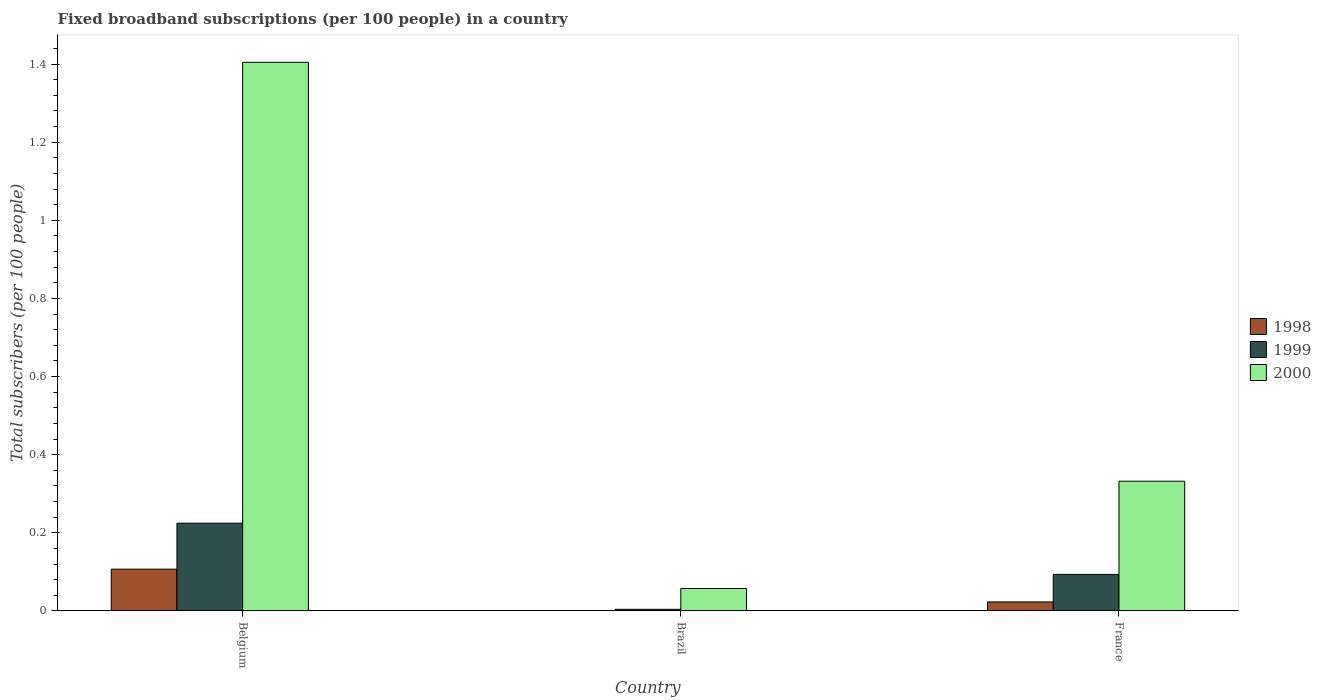How many different coloured bars are there?
Give a very brief answer. 3. How many groups of bars are there?
Offer a terse response. 3. Are the number of bars per tick equal to the number of legend labels?
Offer a terse response. Yes. How many bars are there on the 3rd tick from the left?
Your answer should be compact. 3. How many bars are there on the 1st tick from the right?
Your answer should be very brief. 3. What is the label of the 2nd group of bars from the left?
Provide a succinct answer. Brazil. In how many cases, is the number of bars for a given country not equal to the number of legend labels?
Your answer should be very brief. 0. What is the number of broadband subscriptions in 1999 in Brazil?
Offer a terse response. 0. Across all countries, what is the maximum number of broadband subscriptions in 2000?
Your answer should be very brief. 1.4. Across all countries, what is the minimum number of broadband subscriptions in 1998?
Offer a terse response. 0. In which country was the number of broadband subscriptions in 1999 maximum?
Offer a very short reply. Belgium. In which country was the number of broadband subscriptions in 1999 minimum?
Your answer should be compact. Brazil. What is the total number of broadband subscriptions in 2000 in the graph?
Offer a terse response. 1.79. What is the difference between the number of broadband subscriptions in 2000 in Brazil and that in France?
Offer a terse response. -0.27. What is the difference between the number of broadband subscriptions in 2000 in France and the number of broadband subscriptions in 1999 in Belgium?
Provide a succinct answer. 0.11. What is the average number of broadband subscriptions in 1999 per country?
Give a very brief answer. 0.11. What is the difference between the number of broadband subscriptions of/in 1999 and number of broadband subscriptions of/in 2000 in Belgium?
Offer a terse response. -1.18. What is the ratio of the number of broadband subscriptions in 1998 in Brazil to that in France?
Ensure brevity in your answer.  0.03. What is the difference between the highest and the second highest number of broadband subscriptions in 1998?
Give a very brief answer. 0.08. What is the difference between the highest and the lowest number of broadband subscriptions in 1998?
Keep it short and to the point. 0.11. In how many countries, is the number of broadband subscriptions in 1998 greater than the average number of broadband subscriptions in 1998 taken over all countries?
Make the answer very short. 1. What does the 3rd bar from the left in France represents?
Your response must be concise. 2000. Is it the case that in every country, the sum of the number of broadband subscriptions in 1998 and number of broadband subscriptions in 2000 is greater than the number of broadband subscriptions in 1999?
Make the answer very short. Yes. How many bars are there?
Your answer should be very brief. 9. Are all the bars in the graph horizontal?
Provide a short and direct response. No. What is the difference between two consecutive major ticks on the Y-axis?
Offer a very short reply. 0.2. Are the values on the major ticks of Y-axis written in scientific E-notation?
Offer a very short reply. No. Does the graph contain grids?
Keep it short and to the point. No. Where does the legend appear in the graph?
Your response must be concise. Center right. What is the title of the graph?
Provide a succinct answer. Fixed broadband subscriptions (per 100 people) in a country. Does "1962" appear as one of the legend labels in the graph?
Offer a terse response. No. What is the label or title of the X-axis?
Your response must be concise. Country. What is the label or title of the Y-axis?
Your response must be concise. Total subscribers (per 100 people). What is the Total subscribers (per 100 people) in 1998 in Belgium?
Ensure brevity in your answer.  0.11. What is the Total subscribers (per 100 people) in 1999 in Belgium?
Offer a very short reply. 0.22. What is the Total subscribers (per 100 people) of 2000 in Belgium?
Make the answer very short. 1.4. What is the Total subscribers (per 100 people) in 1998 in Brazil?
Ensure brevity in your answer.  0. What is the Total subscribers (per 100 people) of 1999 in Brazil?
Keep it short and to the point. 0. What is the Total subscribers (per 100 people) in 2000 in Brazil?
Make the answer very short. 0.06. What is the Total subscribers (per 100 people) of 1998 in France?
Make the answer very short. 0.02. What is the Total subscribers (per 100 people) in 1999 in France?
Provide a succinct answer. 0.09. What is the Total subscribers (per 100 people) of 2000 in France?
Provide a succinct answer. 0.33. Across all countries, what is the maximum Total subscribers (per 100 people) in 1998?
Your answer should be compact. 0.11. Across all countries, what is the maximum Total subscribers (per 100 people) of 1999?
Your response must be concise. 0.22. Across all countries, what is the maximum Total subscribers (per 100 people) of 2000?
Keep it short and to the point. 1.4. Across all countries, what is the minimum Total subscribers (per 100 people) of 1998?
Provide a succinct answer. 0. Across all countries, what is the minimum Total subscribers (per 100 people) of 1999?
Your response must be concise. 0. Across all countries, what is the minimum Total subscribers (per 100 people) in 2000?
Provide a short and direct response. 0.06. What is the total Total subscribers (per 100 people) in 1998 in the graph?
Offer a very short reply. 0.13. What is the total Total subscribers (per 100 people) in 1999 in the graph?
Offer a terse response. 0.32. What is the total Total subscribers (per 100 people) in 2000 in the graph?
Your answer should be very brief. 1.79. What is the difference between the Total subscribers (per 100 people) of 1998 in Belgium and that in Brazil?
Your answer should be very brief. 0.11. What is the difference between the Total subscribers (per 100 people) of 1999 in Belgium and that in Brazil?
Keep it short and to the point. 0.22. What is the difference between the Total subscribers (per 100 people) of 2000 in Belgium and that in Brazil?
Provide a short and direct response. 1.35. What is the difference between the Total subscribers (per 100 people) of 1998 in Belgium and that in France?
Make the answer very short. 0.08. What is the difference between the Total subscribers (per 100 people) of 1999 in Belgium and that in France?
Keep it short and to the point. 0.13. What is the difference between the Total subscribers (per 100 people) in 2000 in Belgium and that in France?
Provide a short and direct response. 1.07. What is the difference between the Total subscribers (per 100 people) of 1998 in Brazil and that in France?
Offer a terse response. -0.02. What is the difference between the Total subscribers (per 100 people) in 1999 in Brazil and that in France?
Your answer should be compact. -0.09. What is the difference between the Total subscribers (per 100 people) of 2000 in Brazil and that in France?
Your response must be concise. -0.27. What is the difference between the Total subscribers (per 100 people) of 1998 in Belgium and the Total subscribers (per 100 people) of 1999 in Brazil?
Provide a succinct answer. 0.1. What is the difference between the Total subscribers (per 100 people) in 1998 in Belgium and the Total subscribers (per 100 people) in 2000 in Brazil?
Your answer should be very brief. 0.05. What is the difference between the Total subscribers (per 100 people) in 1999 in Belgium and the Total subscribers (per 100 people) in 2000 in Brazil?
Ensure brevity in your answer.  0.17. What is the difference between the Total subscribers (per 100 people) of 1998 in Belgium and the Total subscribers (per 100 people) of 1999 in France?
Ensure brevity in your answer.  0.01. What is the difference between the Total subscribers (per 100 people) in 1998 in Belgium and the Total subscribers (per 100 people) in 2000 in France?
Keep it short and to the point. -0.23. What is the difference between the Total subscribers (per 100 people) of 1999 in Belgium and the Total subscribers (per 100 people) of 2000 in France?
Provide a short and direct response. -0.11. What is the difference between the Total subscribers (per 100 people) in 1998 in Brazil and the Total subscribers (per 100 people) in 1999 in France?
Give a very brief answer. -0.09. What is the difference between the Total subscribers (per 100 people) of 1998 in Brazil and the Total subscribers (per 100 people) of 2000 in France?
Make the answer very short. -0.33. What is the difference between the Total subscribers (per 100 people) of 1999 in Brazil and the Total subscribers (per 100 people) of 2000 in France?
Your response must be concise. -0.33. What is the average Total subscribers (per 100 people) in 1998 per country?
Give a very brief answer. 0.04. What is the average Total subscribers (per 100 people) of 1999 per country?
Make the answer very short. 0.11. What is the average Total subscribers (per 100 people) of 2000 per country?
Make the answer very short. 0.6. What is the difference between the Total subscribers (per 100 people) in 1998 and Total subscribers (per 100 people) in 1999 in Belgium?
Make the answer very short. -0.12. What is the difference between the Total subscribers (per 100 people) in 1998 and Total subscribers (per 100 people) in 2000 in Belgium?
Offer a very short reply. -1.3. What is the difference between the Total subscribers (per 100 people) in 1999 and Total subscribers (per 100 people) in 2000 in Belgium?
Provide a succinct answer. -1.18. What is the difference between the Total subscribers (per 100 people) in 1998 and Total subscribers (per 100 people) in 1999 in Brazil?
Offer a terse response. -0. What is the difference between the Total subscribers (per 100 people) in 1998 and Total subscribers (per 100 people) in 2000 in Brazil?
Offer a terse response. -0.06. What is the difference between the Total subscribers (per 100 people) in 1999 and Total subscribers (per 100 people) in 2000 in Brazil?
Offer a terse response. -0.05. What is the difference between the Total subscribers (per 100 people) in 1998 and Total subscribers (per 100 people) in 1999 in France?
Keep it short and to the point. -0.07. What is the difference between the Total subscribers (per 100 people) of 1998 and Total subscribers (per 100 people) of 2000 in France?
Make the answer very short. -0.31. What is the difference between the Total subscribers (per 100 people) of 1999 and Total subscribers (per 100 people) of 2000 in France?
Your answer should be very brief. -0.24. What is the ratio of the Total subscribers (per 100 people) in 1998 in Belgium to that in Brazil?
Your answer should be compact. 181.1. What is the ratio of the Total subscribers (per 100 people) in 1999 in Belgium to that in Brazil?
Your answer should be very brief. 55.18. What is the ratio of the Total subscribers (per 100 people) of 2000 in Belgium to that in Brazil?
Offer a terse response. 24.51. What is the ratio of the Total subscribers (per 100 people) of 1998 in Belgium to that in France?
Ensure brevity in your answer.  4.65. What is the ratio of the Total subscribers (per 100 people) in 1999 in Belgium to that in France?
Your answer should be very brief. 2.4. What is the ratio of the Total subscribers (per 100 people) in 2000 in Belgium to that in France?
Your response must be concise. 4.23. What is the ratio of the Total subscribers (per 100 people) in 1998 in Brazil to that in France?
Ensure brevity in your answer.  0.03. What is the ratio of the Total subscribers (per 100 people) of 1999 in Brazil to that in France?
Offer a terse response. 0.04. What is the ratio of the Total subscribers (per 100 people) of 2000 in Brazil to that in France?
Your answer should be very brief. 0.17. What is the difference between the highest and the second highest Total subscribers (per 100 people) in 1998?
Give a very brief answer. 0.08. What is the difference between the highest and the second highest Total subscribers (per 100 people) of 1999?
Provide a short and direct response. 0.13. What is the difference between the highest and the second highest Total subscribers (per 100 people) in 2000?
Provide a succinct answer. 1.07. What is the difference between the highest and the lowest Total subscribers (per 100 people) of 1998?
Offer a very short reply. 0.11. What is the difference between the highest and the lowest Total subscribers (per 100 people) in 1999?
Offer a very short reply. 0.22. What is the difference between the highest and the lowest Total subscribers (per 100 people) of 2000?
Ensure brevity in your answer.  1.35. 